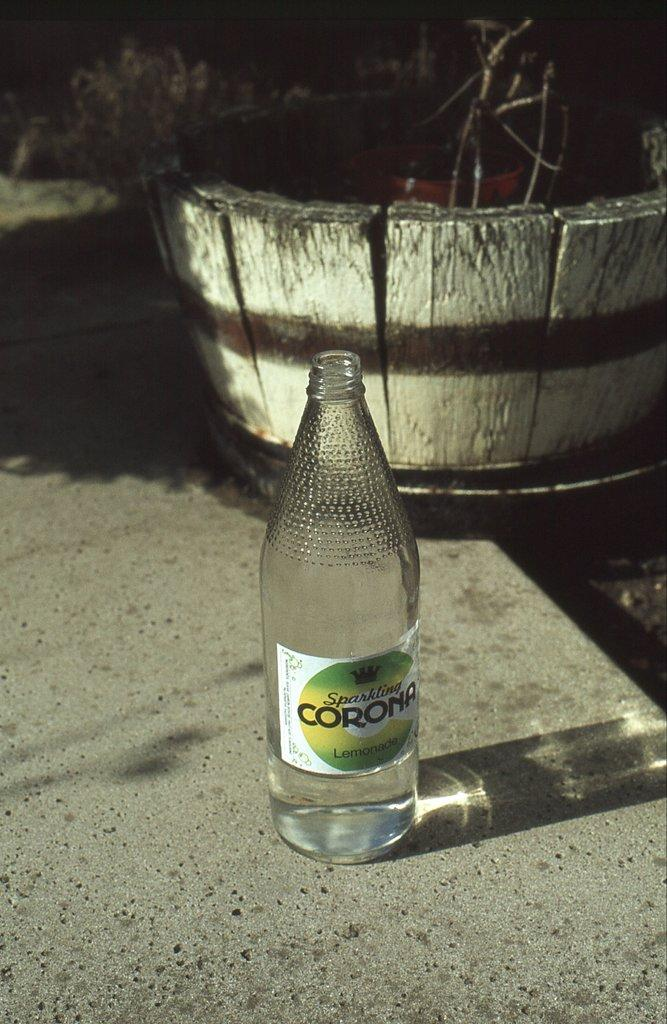What object can be seen in the image that is typically used for holding liquids? There is a bottle in the image that is typically used for holding liquids. What other object can be seen in the image that is related to plants? There is a flower pot in the image that is related to plants. Where are the bottle and the flower pot located in the image? Both the bottle and the flower pot are on the floor in the image. What type of brass seed is visible in the image? There is no brass seed present in the image. 